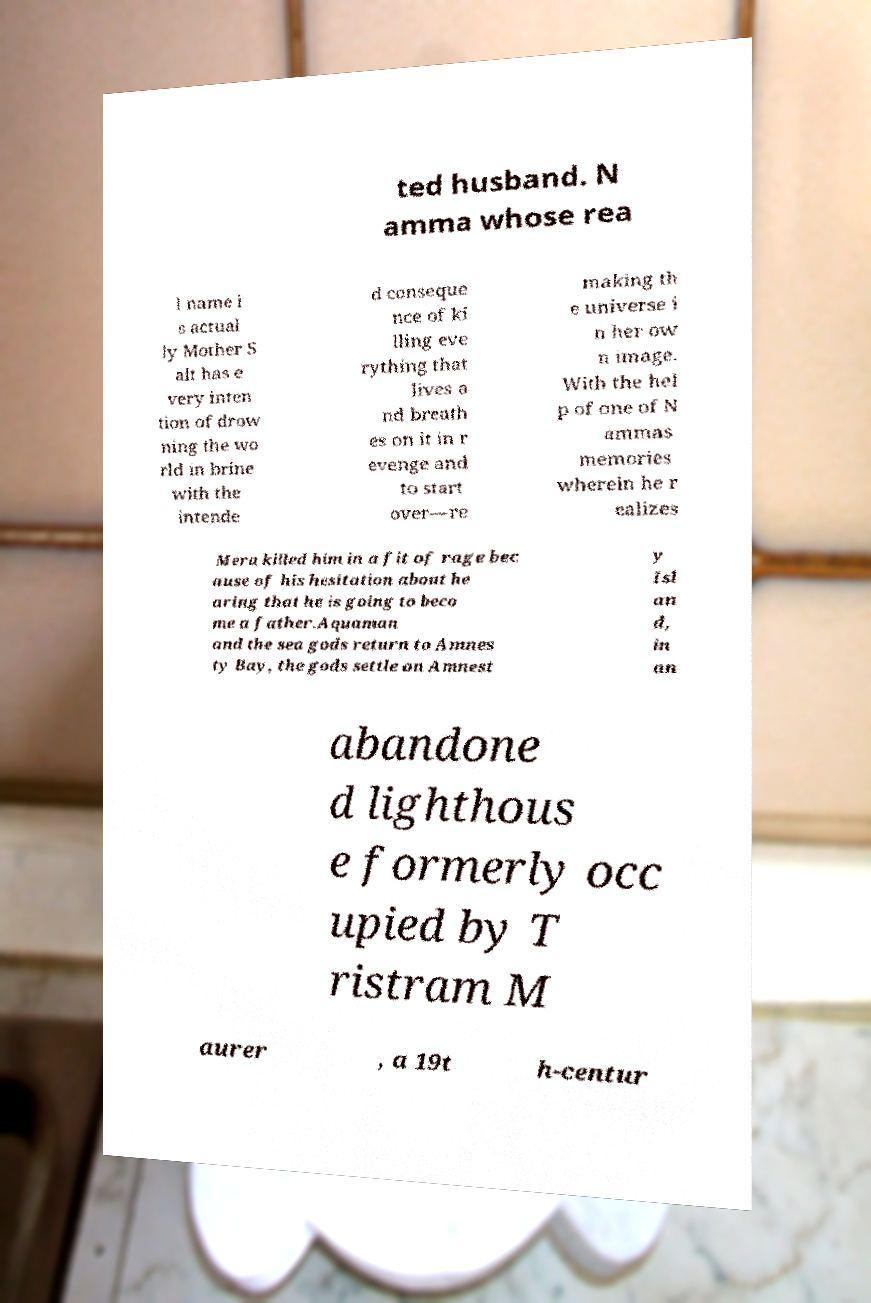What messages or text are displayed in this image? I need them in a readable, typed format. ted husband. N amma whose rea l name i s actual ly Mother S alt has e very inten tion of drow ning the wo rld in brine with the intende d conseque nce of ki lling eve rything that lives a nd breath es on it in r evenge and to start over—re making th e universe i n her ow n image. With the hel p of one of N ammas memories wherein he r ealizes Mera killed him in a fit of rage bec ause of his hesitation about he aring that he is going to beco me a father.Aquaman and the sea gods return to Amnes ty Bay, the gods settle on Amnest y Isl an d, in an abandone d lighthous e formerly occ upied by T ristram M aurer , a 19t h-centur 